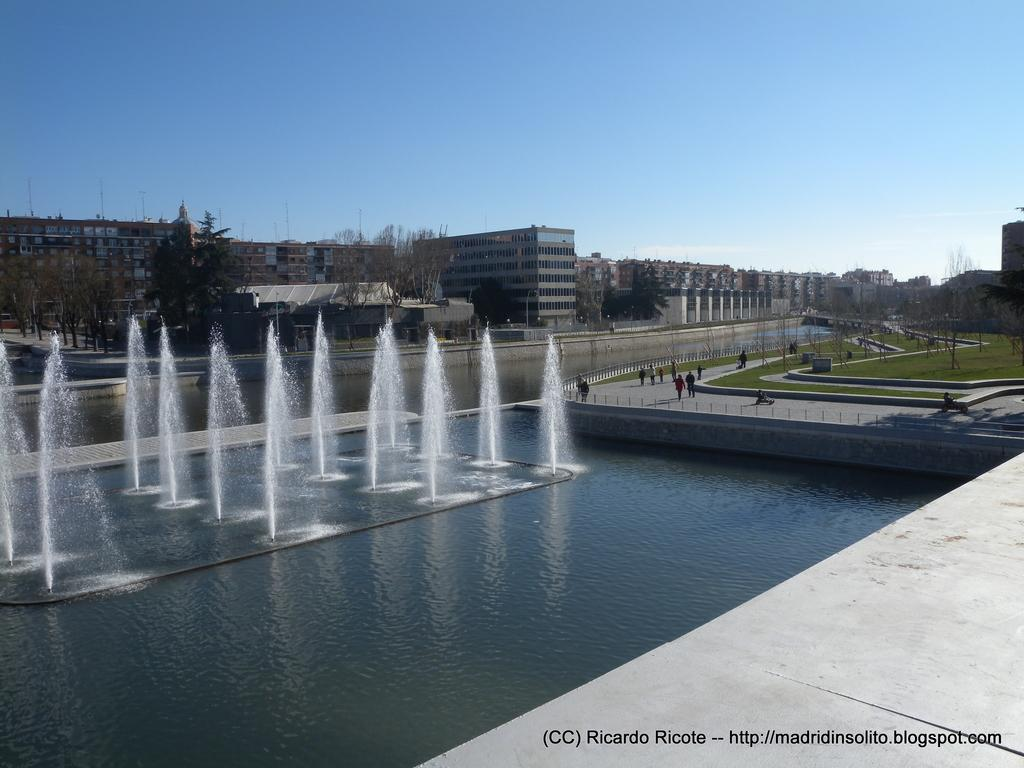What is the main feature in the image? There is a water fountain in the image. What can be seen near the water fountain? There is a walkway in the image. What type of vegetation is present in the image? There is grass in the image. What can be seen in the background of the image? There are trees, buildings, and the sky visible in the background of the image. Is there any text or marking on the image? Yes, there is a watermark on the right side bottom of the image. What type of silk is being used to cover the road in the image? There is no silk or road present in the image. The image features a water fountain, walkway, grass, trees, buildings, sky, and a watermark. 